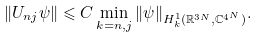Convert formula to latex. <formula><loc_0><loc_0><loc_500><loc_500>\| U _ { n j } \psi \| \leqslant C \min _ { k = n , j } \| \psi \| _ { H ^ { 1 } _ { k } ( \mathbb { R } ^ { 3 N } , \mathbb { C } ^ { 4 ^ { N } } ) } .</formula> 